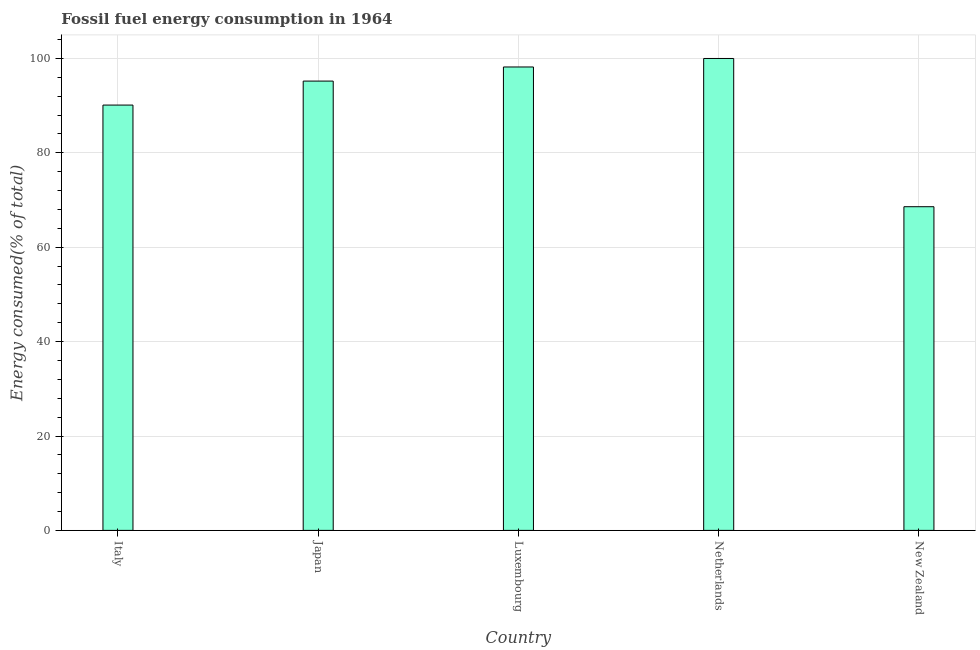What is the title of the graph?
Your response must be concise. Fossil fuel energy consumption in 1964. What is the label or title of the Y-axis?
Offer a terse response. Energy consumed(% of total). What is the fossil fuel energy consumption in New Zealand?
Make the answer very short. 68.58. Across all countries, what is the maximum fossil fuel energy consumption?
Your answer should be very brief. 99.99. Across all countries, what is the minimum fossil fuel energy consumption?
Give a very brief answer. 68.58. In which country was the fossil fuel energy consumption minimum?
Your answer should be compact. New Zealand. What is the sum of the fossil fuel energy consumption?
Provide a succinct answer. 452.09. What is the difference between the fossil fuel energy consumption in Luxembourg and Netherlands?
Your response must be concise. -1.8. What is the average fossil fuel energy consumption per country?
Provide a succinct answer. 90.42. What is the median fossil fuel energy consumption?
Give a very brief answer. 95.2. In how many countries, is the fossil fuel energy consumption greater than 72 %?
Offer a very short reply. 4. What is the ratio of the fossil fuel energy consumption in Luxembourg to that in Netherlands?
Ensure brevity in your answer.  0.98. Is the difference between the fossil fuel energy consumption in Netherlands and New Zealand greater than the difference between any two countries?
Make the answer very short. Yes. What is the difference between the highest and the second highest fossil fuel energy consumption?
Provide a short and direct response. 1.8. Is the sum of the fossil fuel energy consumption in Japan and Luxembourg greater than the maximum fossil fuel energy consumption across all countries?
Your response must be concise. Yes. What is the difference between the highest and the lowest fossil fuel energy consumption?
Provide a short and direct response. 31.41. In how many countries, is the fossil fuel energy consumption greater than the average fossil fuel energy consumption taken over all countries?
Offer a terse response. 3. Are all the bars in the graph horizontal?
Provide a short and direct response. No. What is the difference between two consecutive major ticks on the Y-axis?
Your answer should be compact. 20. What is the Energy consumed(% of total) in Italy?
Provide a short and direct response. 90.12. What is the Energy consumed(% of total) in Japan?
Give a very brief answer. 95.2. What is the Energy consumed(% of total) in Luxembourg?
Make the answer very short. 98.19. What is the Energy consumed(% of total) of Netherlands?
Your answer should be compact. 99.99. What is the Energy consumed(% of total) in New Zealand?
Make the answer very short. 68.58. What is the difference between the Energy consumed(% of total) in Italy and Japan?
Ensure brevity in your answer.  -5.08. What is the difference between the Energy consumed(% of total) in Italy and Luxembourg?
Your response must be concise. -8.07. What is the difference between the Energy consumed(% of total) in Italy and Netherlands?
Provide a succinct answer. -9.87. What is the difference between the Energy consumed(% of total) in Italy and New Zealand?
Your answer should be very brief. 21.54. What is the difference between the Energy consumed(% of total) in Japan and Luxembourg?
Ensure brevity in your answer.  -2.99. What is the difference between the Energy consumed(% of total) in Japan and Netherlands?
Ensure brevity in your answer.  -4.79. What is the difference between the Energy consumed(% of total) in Japan and New Zealand?
Ensure brevity in your answer.  26.62. What is the difference between the Energy consumed(% of total) in Luxembourg and Netherlands?
Offer a very short reply. -1.8. What is the difference between the Energy consumed(% of total) in Luxembourg and New Zealand?
Keep it short and to the point. 29.61. What is the difference between the Energy consumed(% of total) in Netherlands and New Zealand?
Offer a very short reply. 31.41. What is the ratio of the Energy consumed(% of total) in Italy to that in Japan?
Make the answer very short. 0.95. What is the ratio of the Energy consumed(% of total) in Italy to that in Luxembourg?
Offer a terse response. 0.92. What is the ratio of the Energy consumed(% of total) in Italy to that in Netherlands?
Offer a very short reply. 0.9. What is the ratio of the Energy consumed(% of total) in Italy to that in New Zealand?
Your answer should be very brief. 1.31. What is the ratio of the Energy consumed(% of total) in Japan to that in Luxembourg?
Offer a very short reply. 0.97. What is the ratio of the Energy consumed(% of total) in Japan to that in Netherlands?
Offer a terse response. 0.95. What is the ratio of the Energy consumed(% of total) in Japan to that in New Zealand?
Your answer should be very brief. 1.39. What is the ratio of the Energy consumed(% of total) in Luxembourg to that in Netherlands?
Offer a very short reply. 0.98. What is the ratio of the Energy consumed(% of total) in Luxembourg to that in New Zealand?
Give a very brief answer. 1.43. What is the ratio of the Energy consumed(% of total) in Netherlands to that in New Zealand?
Offer a terse response. 1.46. 